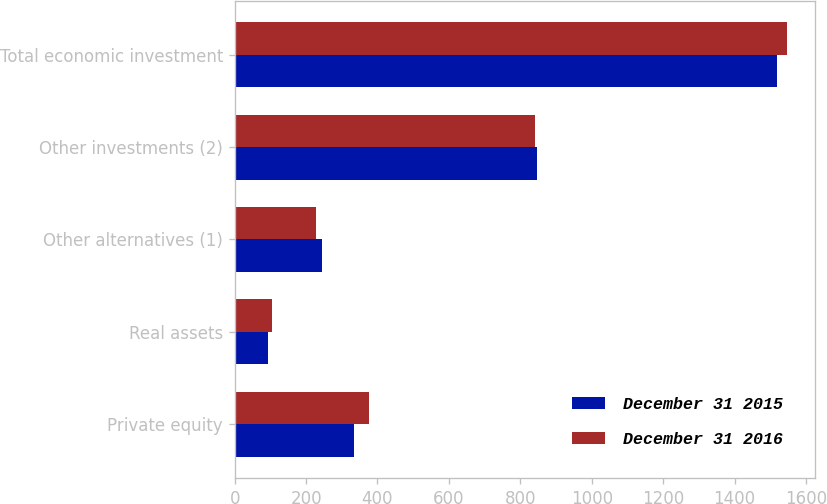Convert chart. <chart><loc_0><loc_0><loc_500><loc_500><stacked_bar_chart><ecel><fcel>Private equity<fcel>Real assets<fcel>Other alternatives (1)<fcel>Other investments (2)<fcel>Total economic investment<nl><fcel>December 31 2015<fcel>334<fcel>94<fcel>245<fcel>846<fcel>1519<nl><fcel>December 31 2016<fcel>375<fcel>104<fcel>227<fcel>842<fcel>1548<nl></chart> 